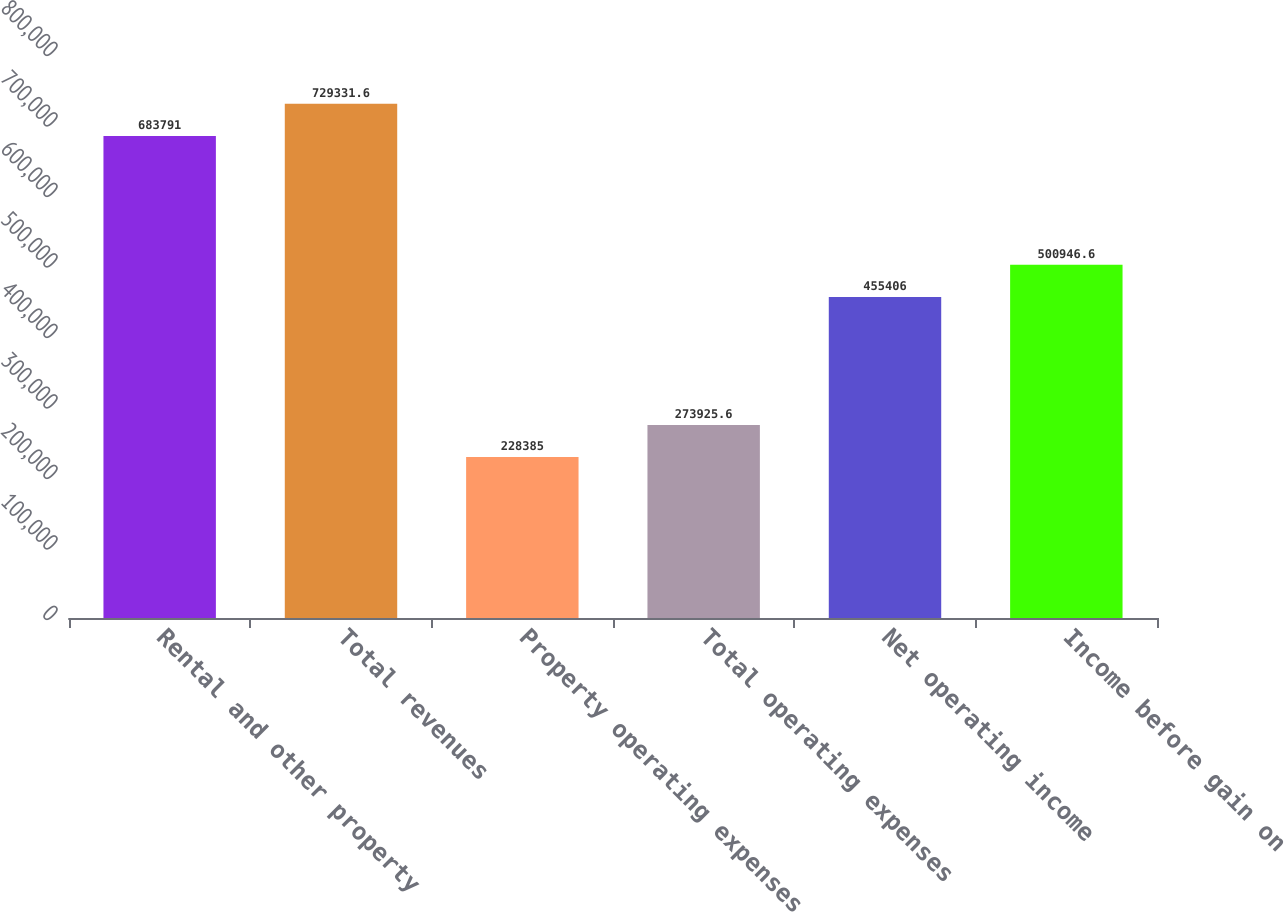Convert chart. <chart><loc_0><loc_0><loc_500><loc_500><bar_chart><fcel>Rental and other property<fcel>Total revenues<fcel>Property operating expenses<fcel>Total operating expenses<fcel>Net operating income<fcel>Income before gain on<nl><fcel>683791<fcel>729332<fcel>228385<fcel>273926<fcel>455406<fcel>500947<nl></chart> 